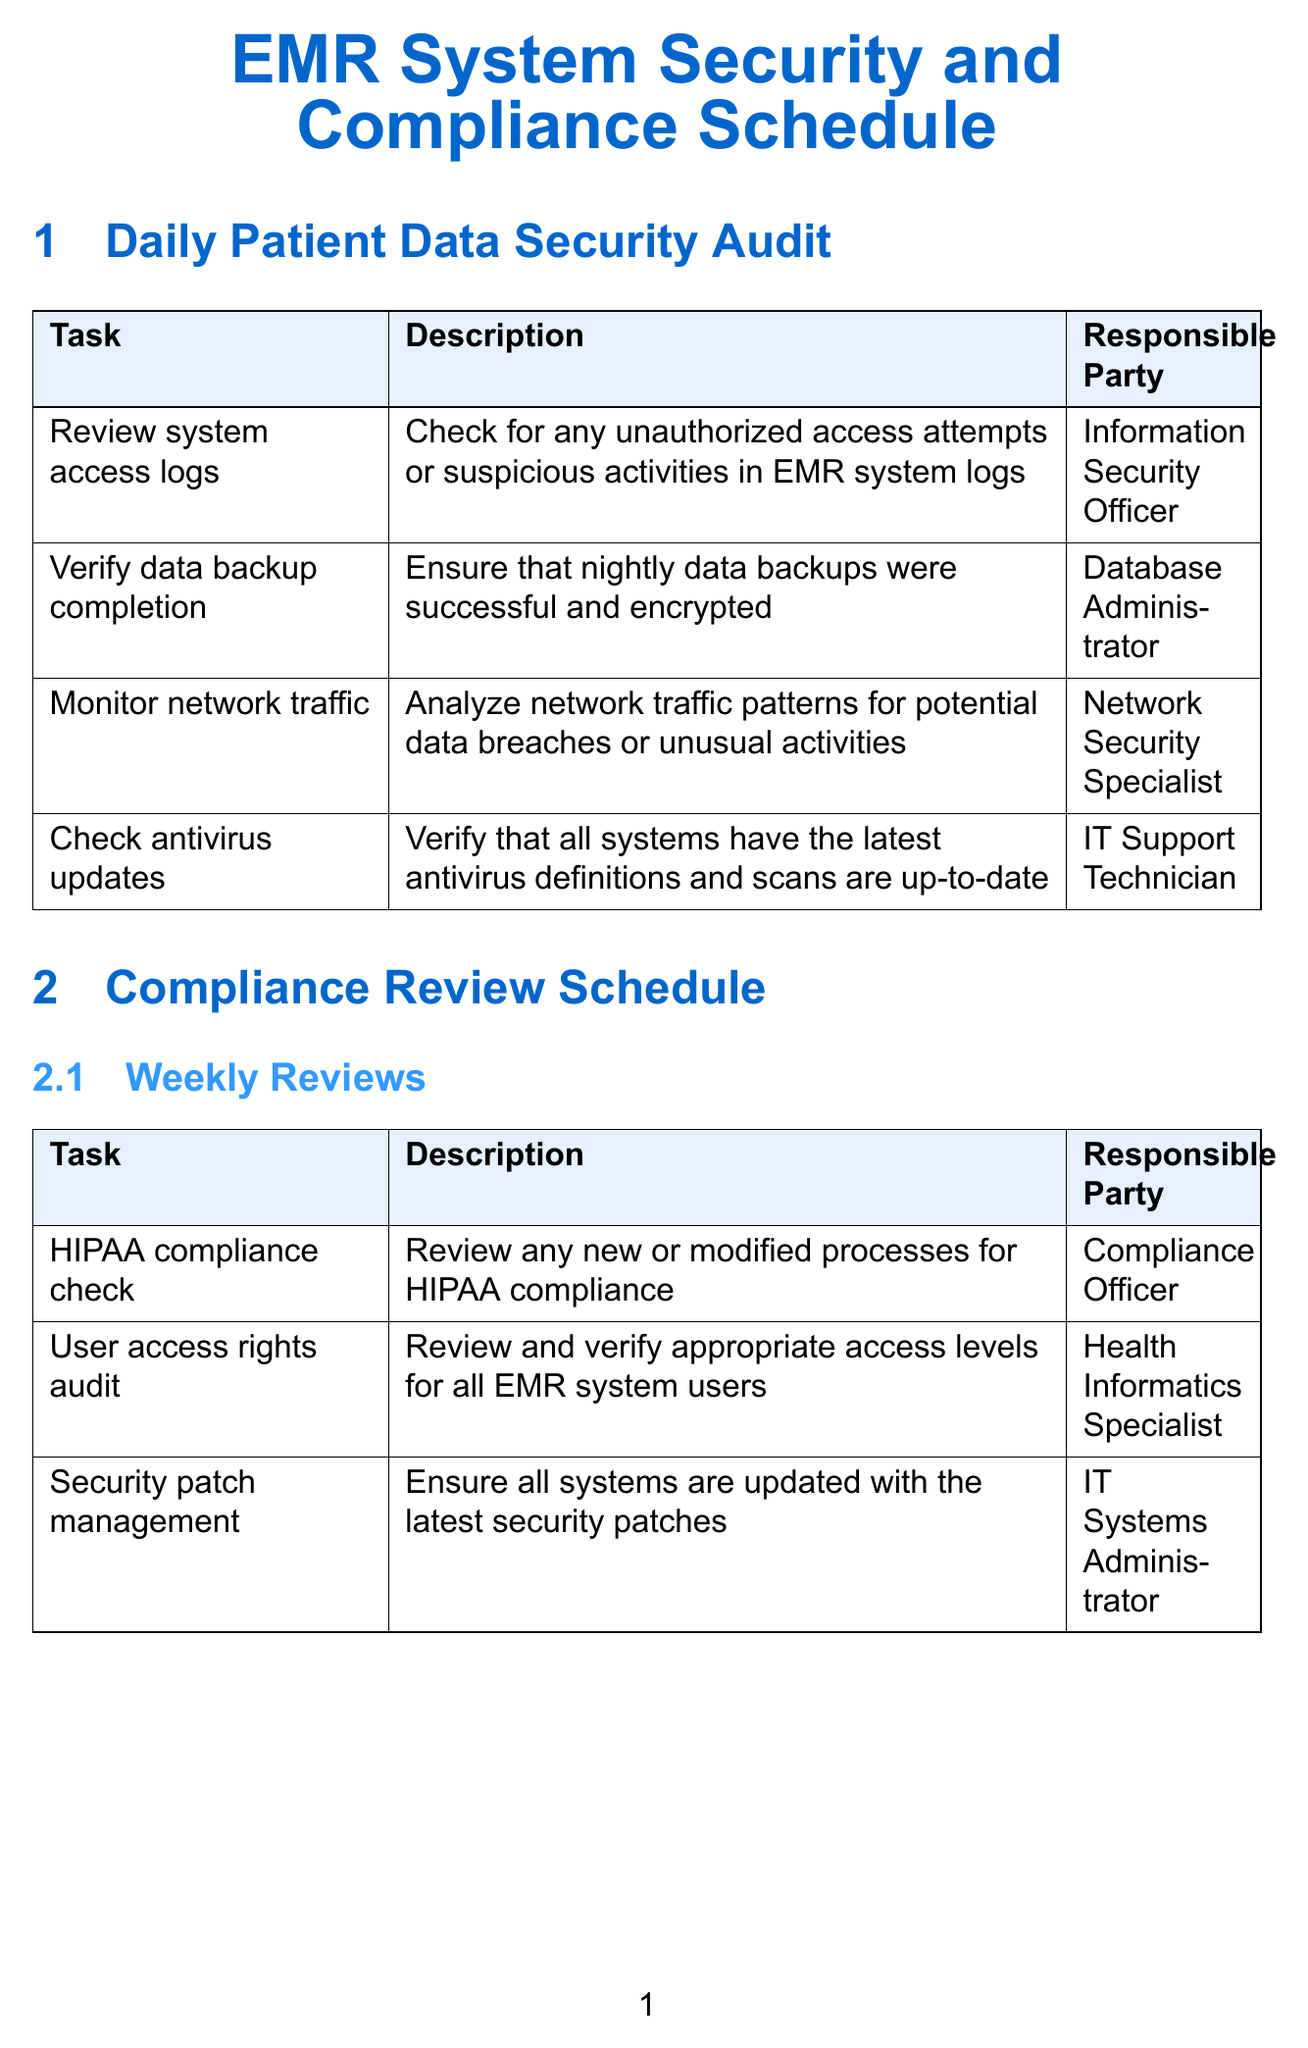What is the responsible party for checking antivirus updates? The responsible party for checking antivirus updates is listed in the daily audit tasks section of the document.
Answer: IT Support Technician How often is the data encryption audit performed? The frequency of the data encryption audit is specified in the monthly compliance reviews section.
Answer: Monthly What task involves reviewing user access rights? This specific task is mentioned in the weekly compliance reviews section.
Answer: User access rights audit Who conducts the full security risk assessment? The individual responsible for this task is indicated in the annual compliance reviews section.
Answer: Chief Information Security Officer What is the purpose of the staff security training? The purpose is provided in the quarterly reviews section, focusing on educating staff about security.
Answer: Security awareness training How many daily audit tasks are listed in the document? The total number of tasks in the daily audit section needs to be counted from the table.
Answer: Four Which compliance review task is related to the HITECH Act? This specific task is found in the quarterly compliance reviews section.
Answer: HITECH Act compliance audit What is verified in the disaster recovery plan review? The description of this task explains what is checked in the review, mentioned in the monthly compliance reviews.
Answer: Update and test What action is associated with vendor management related to patient data? The task outlines the security assessment of vendors and is found in the monthly reviews section.
Answer: Security practices review How frequently are the security patch management reviews performed? The frequency is noted in the weekly compliance reviews section.
Answer: Weekly 